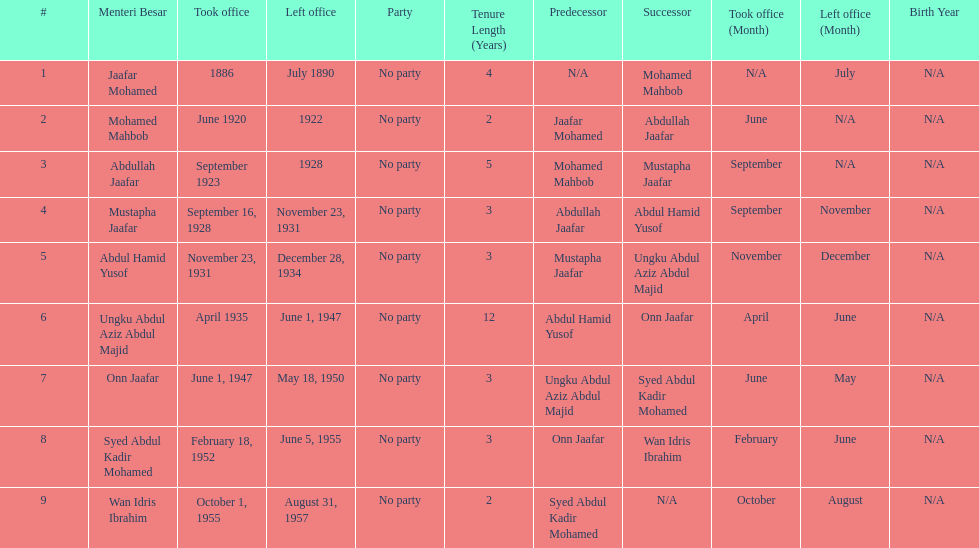How many years was jaafar mohamed in office? 4. 